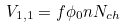Convert formula to latex. <formula><loc_0><loc_0><loc_500><loc_500>V _ { 1 , 1 } = f \phi _ { 0 } n N _ { c h }</formula> 